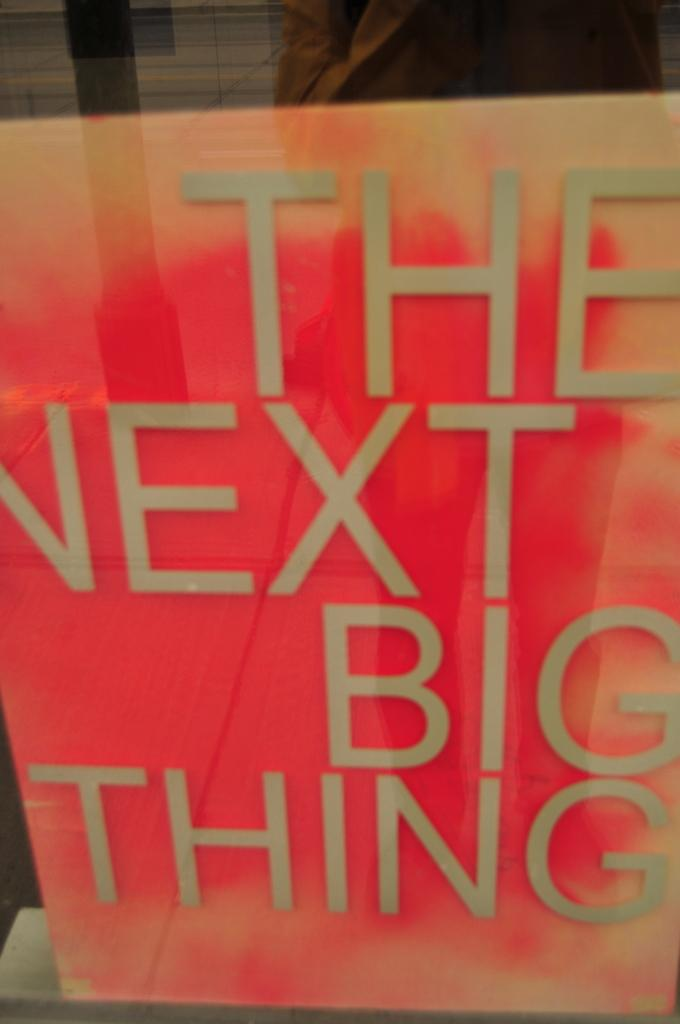Provide a one-sentence caption for the provided image. Orange book with large text that reads " The Next Big Thing". 